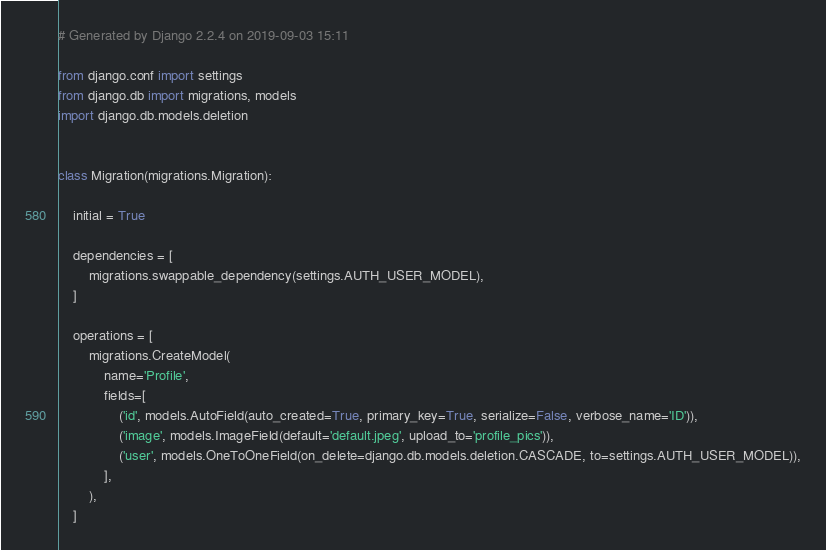<code> <loc_0><loc_0><loc_500><loc_500><_Python_># Generated by Django 2.2.4 on 2019-09-03 15:11

from django.conf import settings
from django.db import migrations, models
import django.db.models.deletion


class Migration(migrations.Migration):

    initial = True

    dependencies = [
        migrations.swappable_dependency(settings.AUTH_USER_MODEL),
    ]

    operations = [
        migrations.CreateModel(
            name='Profile',
            fields=[
                ('id', models.AutoField(auto_created=True, primary_key=True, serialize=False, verbose_name='ID')),
                ('image', models.ImageField(default='default.jpeg', upload_to='profile_pics')),
                ('user', models.OneToOneField(on_delete=django.db.models.deletion.CASCADE, to=settings.AUTH_USER_MODEL)),
            ],
        ),
    ]
</code> 